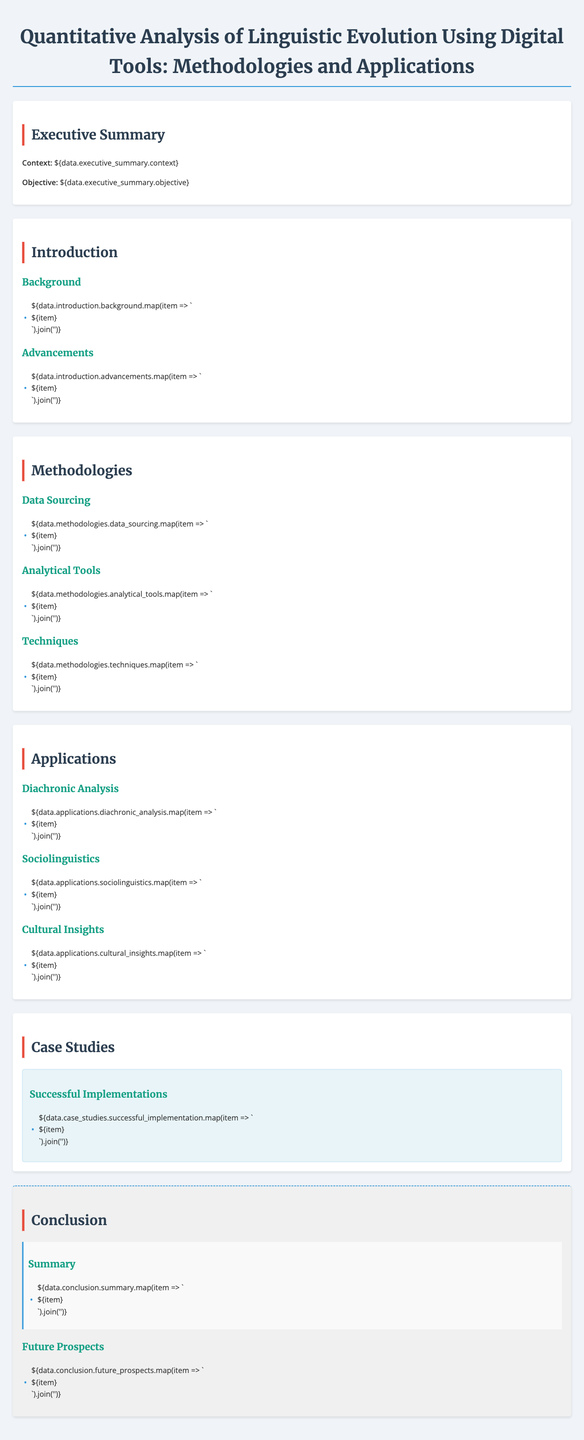What is the main objective of the paper? The main objective is to analyze linguistic evolution using various digital methodologies.
Answer: Analyze linguistic evolution What are the key advancements in linguistic analysis mentioned? Key advancements refer to new methods and tools that enhance analysis of historical texts.
Answer: New methods and tools How many methodologies are discussed in the document? The document outlines three main methodologies related to linguistic analysis.
Answer: Three What type of analysis is used in Cultural Insights applications? The type of analysis focuses on how language reflects societal changes and cultural contexts.
Answer: Societal changes and cultural contexts Which section provides successful implementation examples? The section titled "Case Studies" shares examples of successful applications of the discussed methodologies.
Answer: Case Studies What is one of the future prospects mentioned in the conclusion? Future prospects might involve developing new analytical tools and frameworks for better analysis.
Answer: New analytical tools and frameworks What are the main analytical tools referenced? The document refers to specific analytical tools that aid in linguistic analysis.
Answer: Specific analytical tools How does sociolinguistics contribute to this field according to the document? Sociolinguistics contributes by examining language variation and social influences over time.
Answer: Language variation and social influences 